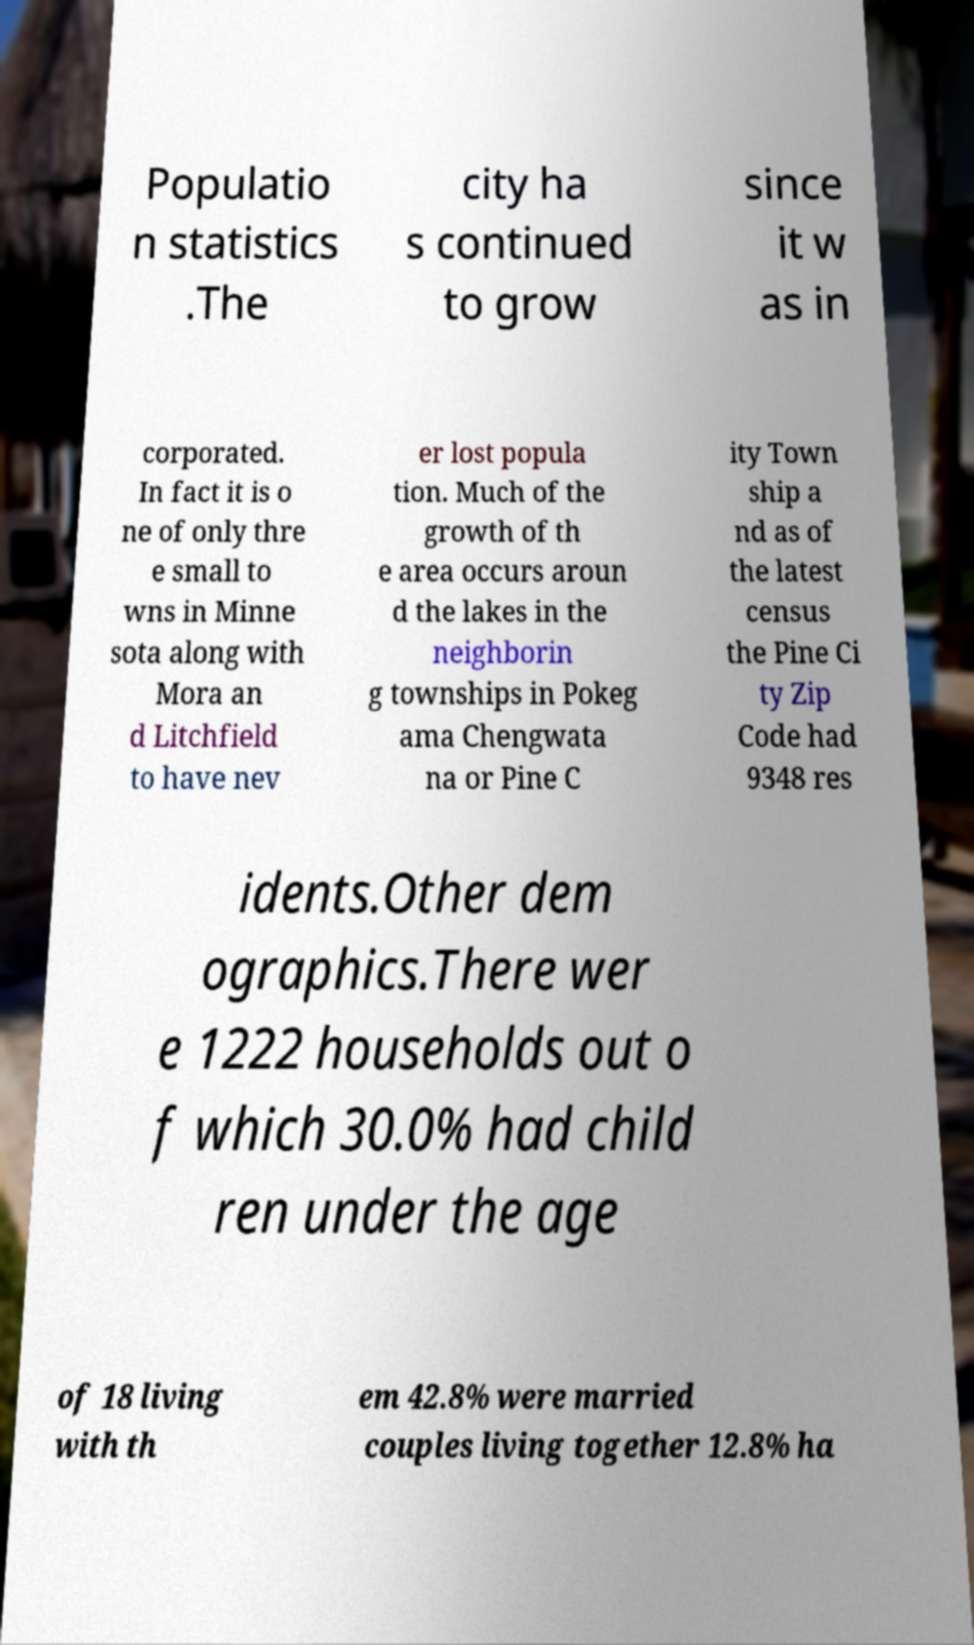Could you extract and type out the text from this image? Populatio n statistics .The city ha s continued to grow since it w as in corporated. In fact it is o ne of only thre e small to wns in Minne sota along with Mora an d Litchfield to have nev er lost popula tion. Much of the growth of th e area occurs aroun d the lakes in the neighborin g townships in Pokeg ama Chengwata na or Pine C ity Town ship a nd as of the latest census the Pine Ci ty Zip Code had 9348 res idents.Other dem ographics.There wer e 1222 households out o f which 30.0% had child ren under the age of 18 living with th em 42.8% were married couples living together 12.8% ha 